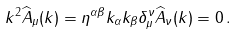<formula> <loc_0><loc_0><loc_500><loc_500>k ^ { 2 } \widehat { A } _ { \mu } ( k ) = \eta ^ { \alpha \beta } k _ { \alpha } k _ { \beta } \delta _ { \mu } ^ { \nu } \widehat { A } _ { \nu } ( k ) = 0 \, .</formula> 